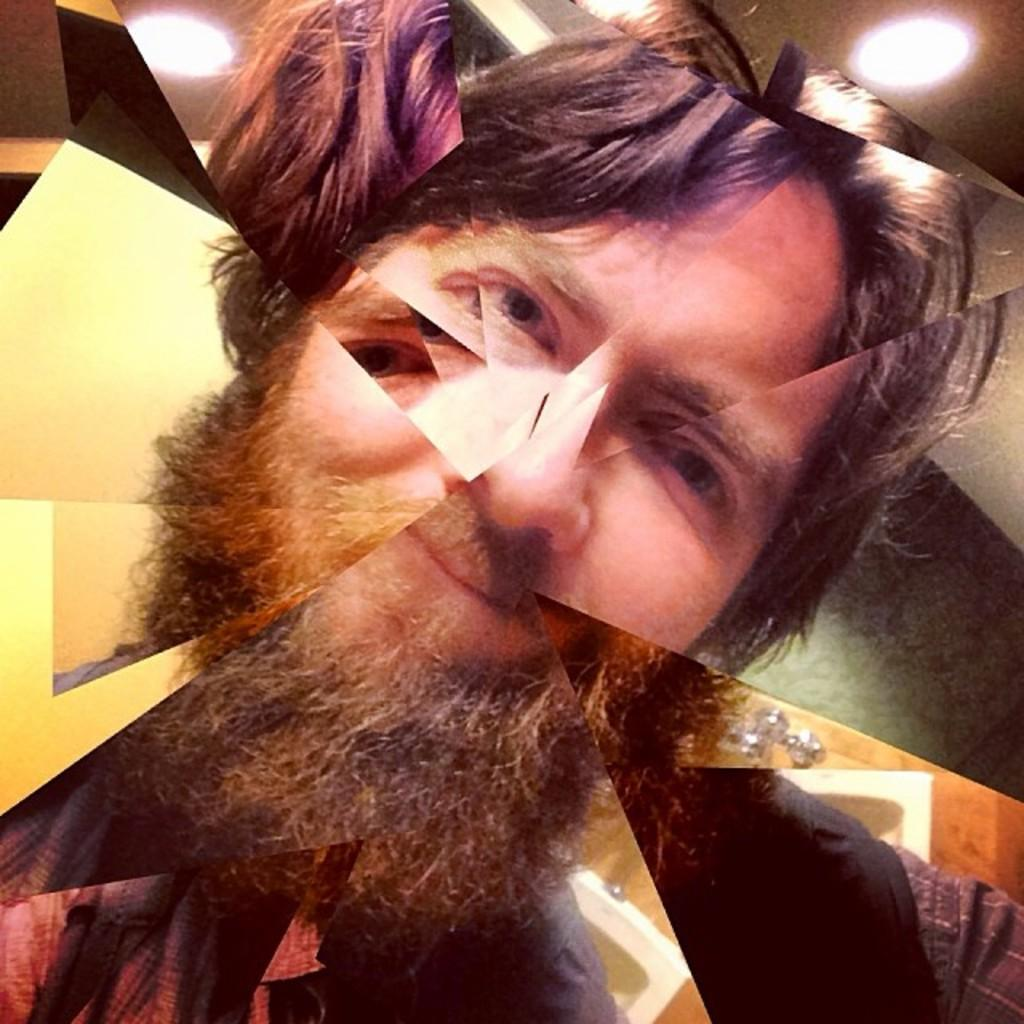What is the main subject of the image? The main subject of the image is multiple faces of a person. Can you describe the lighting in the image? There are lights visible in the image. Where is the bell located in the image? There is no bell present in the image. What type of chicken can be seen in the image? There is no chicken present in the image. 